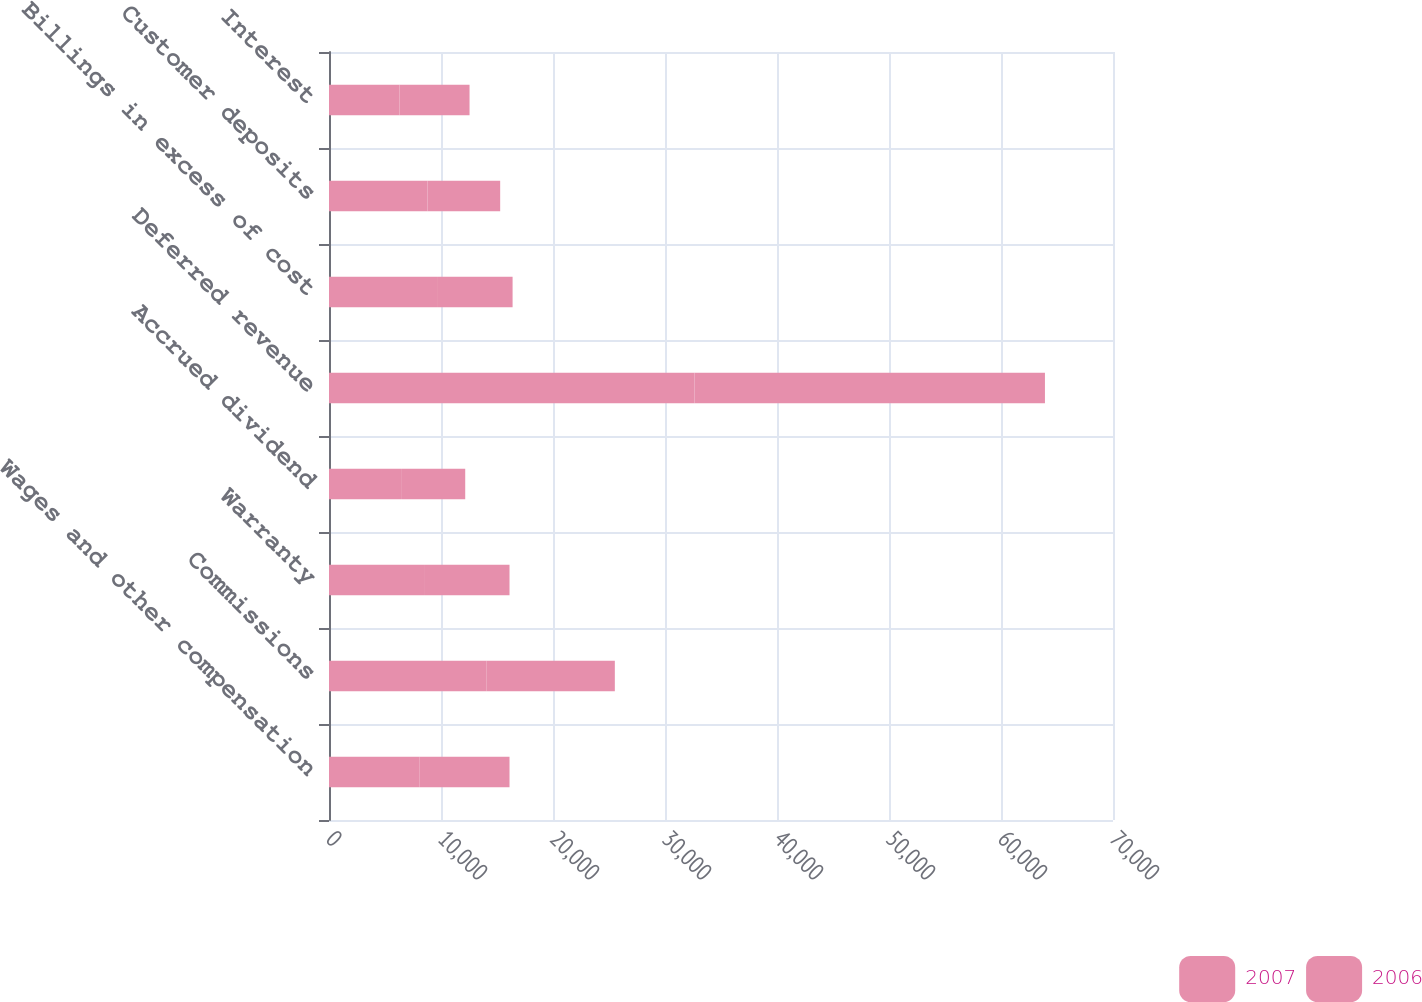Convert chart to OTSL. <chart><loc_0><loc_0><loc_500><loc_500><stacked_bar_chart><ecel><fcel>Wages and other compensation<fcel>Commissions<fcel>Warranty<fcel>Accrued dividend<fcel>Deferred revenue<fcel>Billings in excess of cost<fcel>Customer deposits<fcel>Interest<nl><fcel>2007<fcel>8059<fcel>14081<fcel>8486<fcel>6438<fcel>32638<fcel>9728<fcel>8794<fcel>6299<nl><fcel>2006<fcel>8059<fcel>11440<fcel>7632<fcel>5725<fcel>31286<fcel>6664<fcel>6490<fcel>6250<nl></chart> 